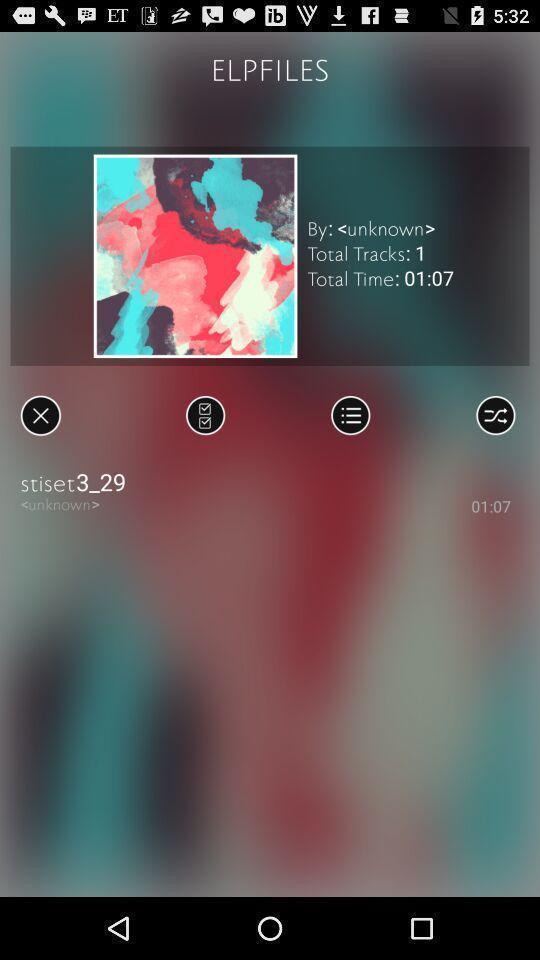Give me a narrative description of this picture. Page for the music application. 